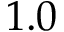<formula> <loc_0><loc_0><loc_500><loc_500>1 . 0</formula> 